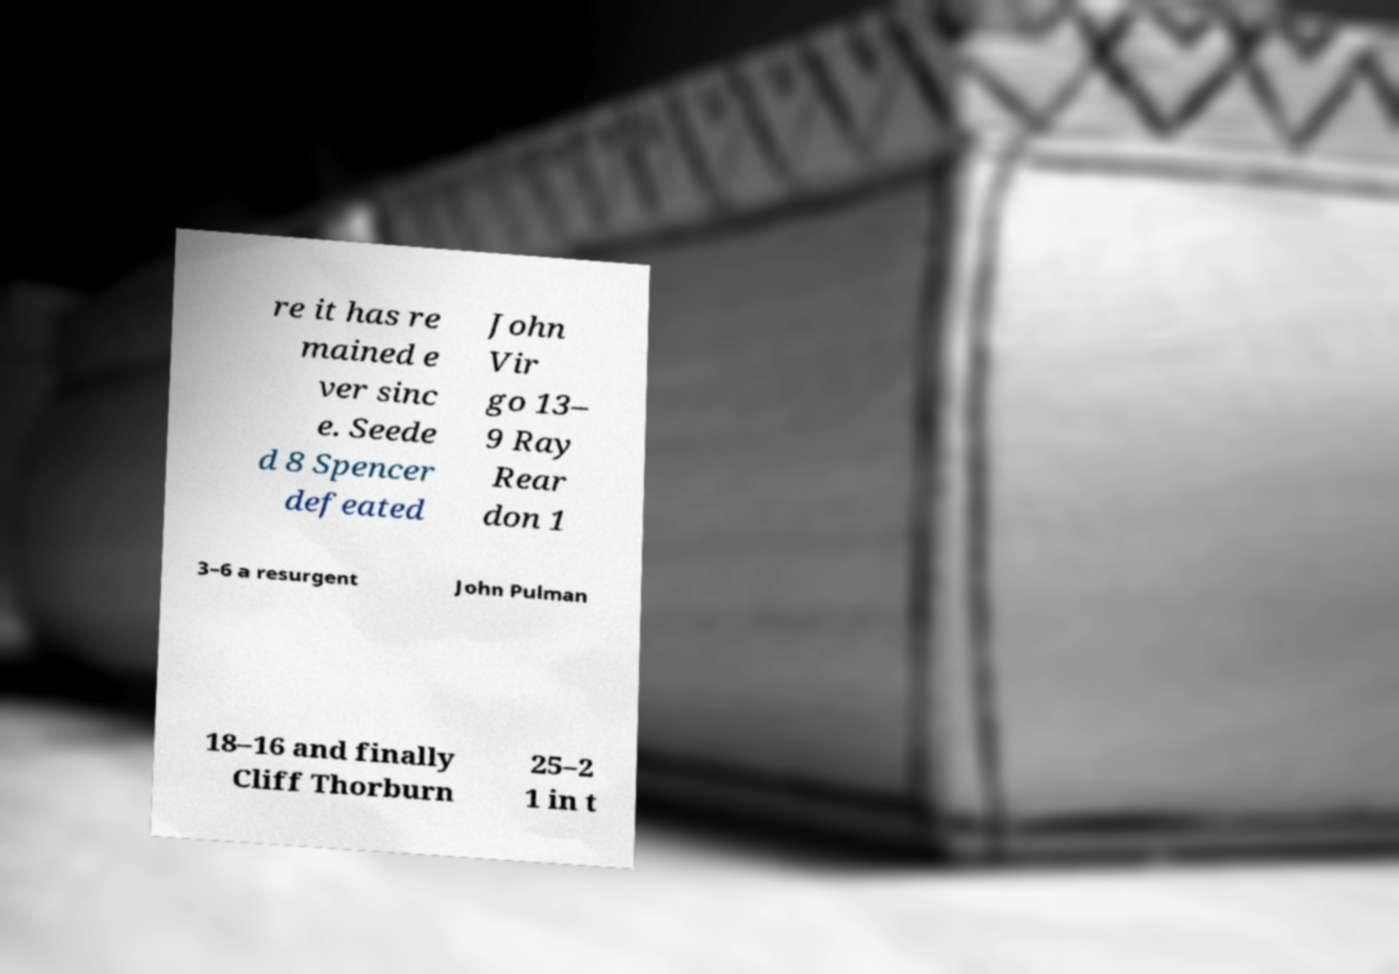Please identify and transcribe the text found in this image. re it has re mained e ver sinc e. Seede d 8 Spencer defeated John Vir go 13– 9 Ray Rear don 1 3–6 a resurgent John Pulman 18–16 and finally Cliff Thorburn 25–2 1 in t 